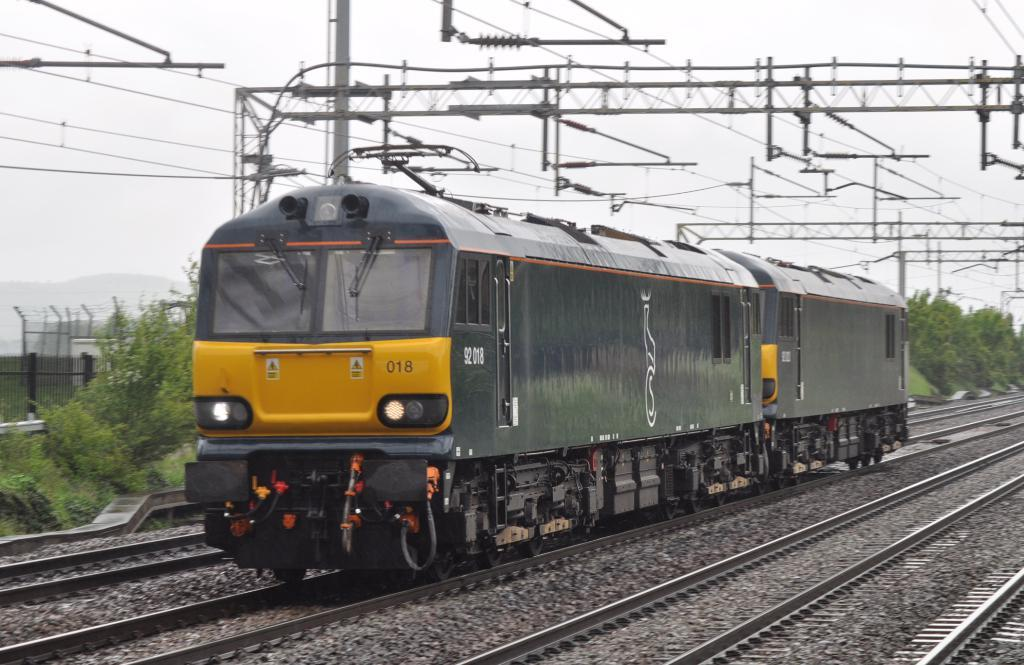<image>
Relay a brief, clear account of the picture shown. A train has the number 18 on the front and is on tracks. 